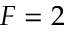<formula> <loc_0><loc_0><loc_500><loc_500>F = 2</formula> 